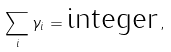<formula> <loc_0><loc_0><loc_500><loc_500>\sum _ { i } \gamma _ { i } = \text {integer} \, ,</formula> 